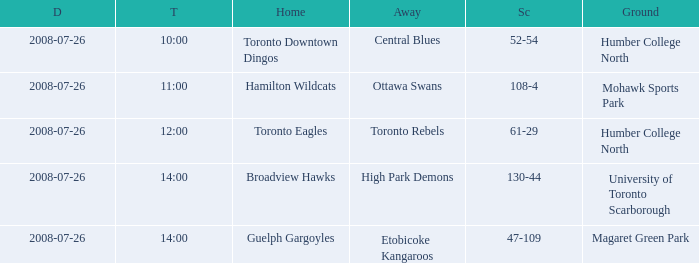The Away High Park Demons was which Ground? University of Toronto Scarborough. 